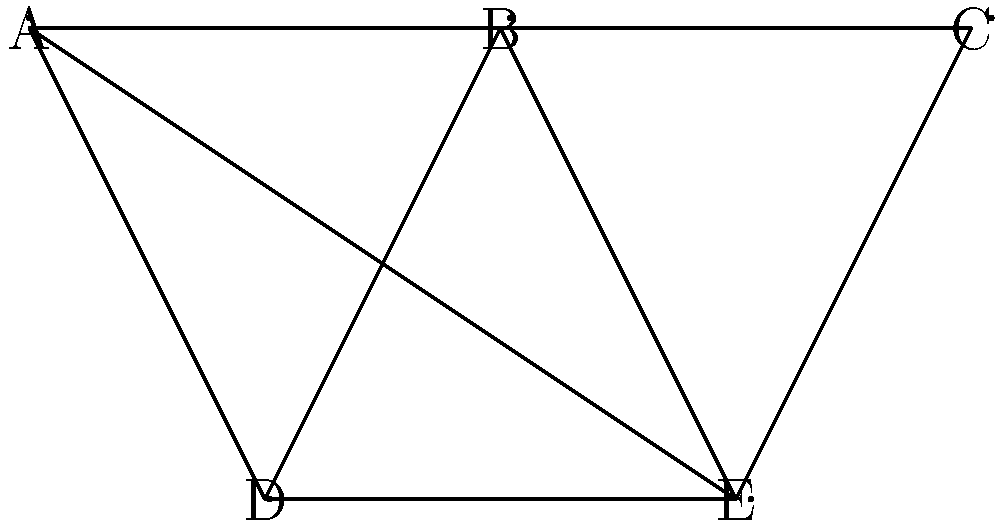As the royal event coordinator, you're tasked with scheduling five prestigious gatherings (A, B, C, D, E) across various venues in London. The graph represents scheduling conflicts, where connected events cannot occur simultaneously. What is the minimum number of time slots needed to schedule all events without conflicts? To solve this problem, we need to approach it as a graph coloring challenge:

1. Each node represents an event, and edges represent conflicts.
2. The goal is to assign colors (time slots) to nodes so that no adjacent nodes have the same color.
3. The minimum number of colors needed is equivalent to the chromatic number of the graph.

Let's color the graph step by step:

1. Start with event A. Assign it color 1.
2. Event B is connected to A, so it needs a different color. Assign color 2.
3. Event C is connected to B but not A. It can use color 1.
4. Event D is connected to A and B. It needs a new color, 3.
5. Event E is connected to A, B, and C. It needs a new color, 4.

We've used 4 colors in total, and no adjacent nodes have the same color.

To verify this is the minimum:
- The graph contains a clique (fully connected subgraph) of size 3 (A, B, E), which requires at least 3 colors.
- E is connected to this clique and to C, necessitating a 4th color.

Therefore, the chromatic number of this graph is 4, meaning 4 time slots are needed.
Answer: 4 time slots 